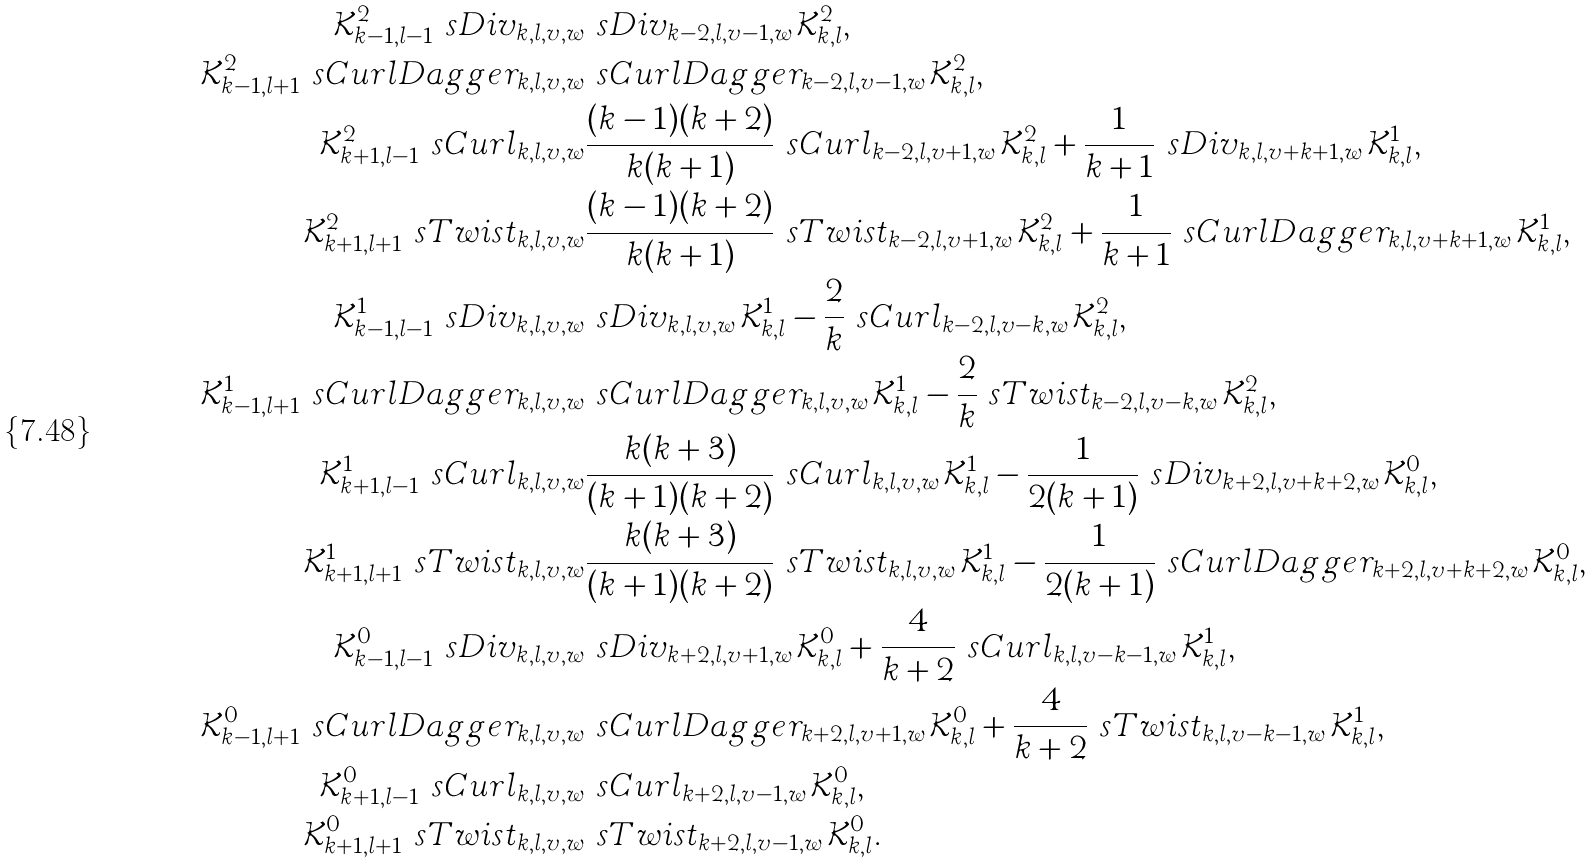Convert formula to latex. <formula><loc_0><loc_0><loc_500><loc_500>\mathcal { K } ^ { 2 } _ { k - 1 , l - 1 } \ s D i v _ { k , l , v , w } & \ s D i v _ { k - 2 , l , v - 1 , w } \mathcal { K } ^ { 2 } _ { k , l } , \\ \mathcal { K } ^ { 2 } _ { k - 1 , l + 1 } \ s C u r l D a g g e r _ { k , l , v , w } & \ s C u r l D a g g e r _ { k - 2 , l , v - 1 , w } \mathcal { K } ^ { 2 } _ { k , l } , \\ \mathcal { K } ^ { 2 } _ { k + 1 , l - 1 } \ s C u r l _ { k , l , v , w } & \frac { ( k - 1 ) ( k + 2 ) } { k ( k + 1 ) } \ s C u r l _ { k - 2 , l , v + 1 , w } \mathcal { K } ^ { 2 } _ { k , l } + \frac { 1 } { k + 1 } \ s D i v _ { k , l , v + k + 1 , w } \mathcal { K } ^ { 1 } _ { k , l } , \\ \mathcal { K } ^ { 2 } _ { k + 1 , l + 1 } \ s T w i s t _ { k , l , v , w } & \frac { ( k - 1 ) ( k + 2 ) } { k ( k + 1 ) } \ s T w i s t _ { k - 2 , l , v + 1 , w } \mathcal { K } ^ { 2 } _ { k , l } + \frac { 1 } { k + 1 } \ s C u r l D a g g e r _ { k , l , v + k + 1 , w } \mathcal { K } ^ { 1 } _ { k , l } , \\ \mathcal { K } ^ { 1 } _ { k - 1 , l - 1 } \ s D i v _ { k , l , v , w } & \ s D i v _ { k , l , v , w } \mathcal { K } ^ { 1 } _ { k , l } - \frac { 2 } { k } \ s C u r l _ { k - 2 , l , v - k , w } \mathcal { K } ^ { 2 } _ { k , l } , \\ \mathcal { K } ^ { 1 } _ { k - 1 , l + 1 } \ s C u r l D a g g e r _ { k , l , v , w } & \ s C u r l D a g g e r _ { k , l , v , w } \mathcal { K } ^ { 1 } _ { k , l } - \frac { 2 } { k } \ s T w i s t _ { k - 2 , l , v - k , w } \mathcal { K } ^ { 2 } _ { k , l } , \\ \mathcal { K } ^ { 1 } _ { k + 1 , l - 1 } \ s C u r l _ { k , l , v , w } & \frac { k ( k + 3 ) } { ( k + 1 ) ( k + 2 ) } \ s C u r l _ { k , l , v , w } \mathcal { K } ^ { 1 } _ { k , l } - \frac { 1 } { 2 ( k + 1 ) } \ s D i v _ { k + 2 , l , v + k + 2 , w } \mathcal { K } ^ { 0 } _ { k , l } , \\ \mathcal { K } ^ { 1 } _ { k + 1 , l + 1 } \ s T w i s t _ { k , l , v , w } & \frac { k ( k + 3 ) } { ( k + 1 ) ( k + 2 ) } \ s T w i s t _ { k , l , v , w } \mathcal { K } ^ { 1 } _ { k , l } - \frac { 1 } { 2 ( k + 1 ) } \ s C u r l D a g g e r _ { k + 2 , l , v + k + 2 , w } \mathcal { K } ^ { 0 } _ { k , l } , \\ \mathcal { K } ^ { 0 } _ { k - 1 , l - 1 } \ s D i v _ { k , l , v , w } & \ s D i v _ { k + 2 , l , v + 1 , w } \mathcal { K } ^ { 0 } _ { k , l } + \frac { 4 } { k + 2 } \ s C u r l _ { k , l , v - k - 1 , w } \mathcal { K } ^ { 1 } _ { k , l } , \\ \mathcal { K } ^ { 0 } _ { k - 1 , l + 1 } \ s C u r l D a g g e r _ { k , l , v , w } & \ s C u r l D a g g e r _ { k + 2 , l , v + 1 , w } \mathcal { K } ^ { 0 } _ { k , l } + \frac { 4 } { k + 2 } \ s T w i s t _ { k , l , v - k - 1 , w } \mathcal { K } ^ { 1 } _ { k , l } , \\ \mathcal { K } ^ { 0 } _ { k + 1 , l - 1 } \ s C u r l _ { k , l , v , w } & \ s C u r l _ { k + 2 , l , v - 1 , w } \mathcal { K } ^ { 0 } _ { k , l } , \\ \mathcal { K } ^ { 0 } _ { k + 1 , l + 1 } \ s T w i s t _ { k , l , v , w } & \ s T w i s t _ { k + 2 , l , v - 1 , w } \mathcal { K } ^ { 0 } _ { k , l } .</formula> 